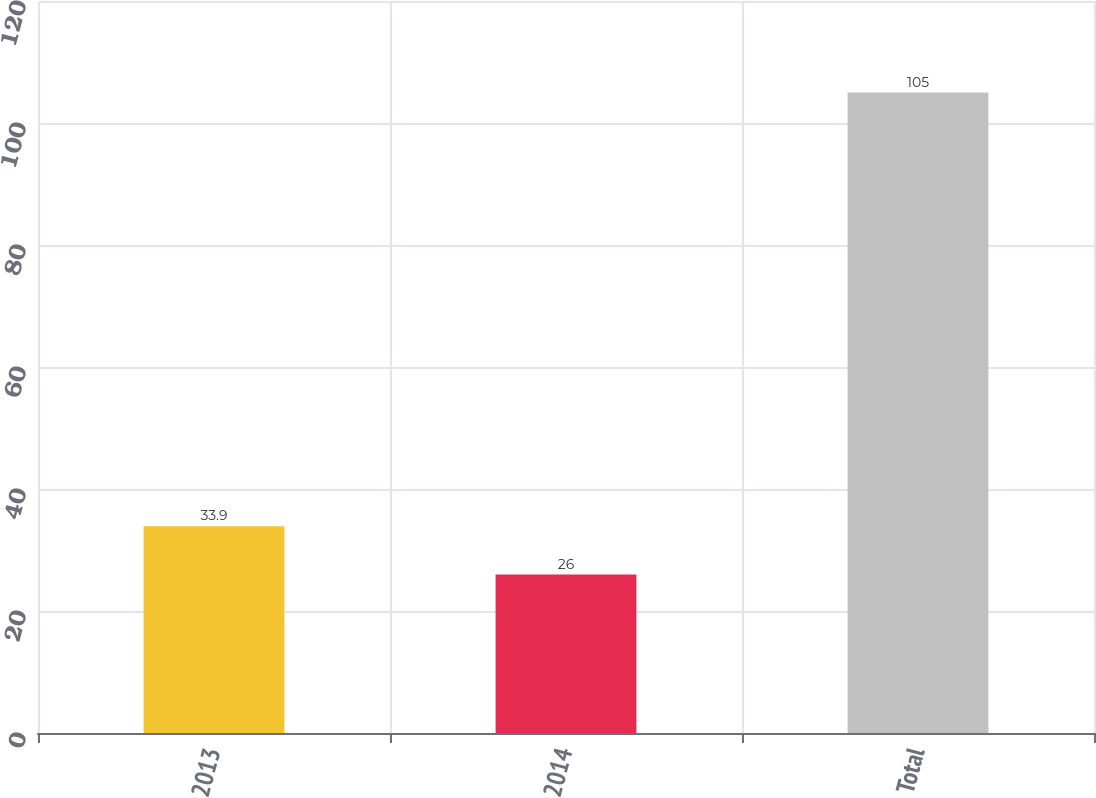<chart> <loc_0><loc_0><loc_500><loc_500><bar_chart><fcel>2013<fcel>2014<fcel>Total<nl><fcel>33.9<fcel>26<fcel>105<nl></chart> 